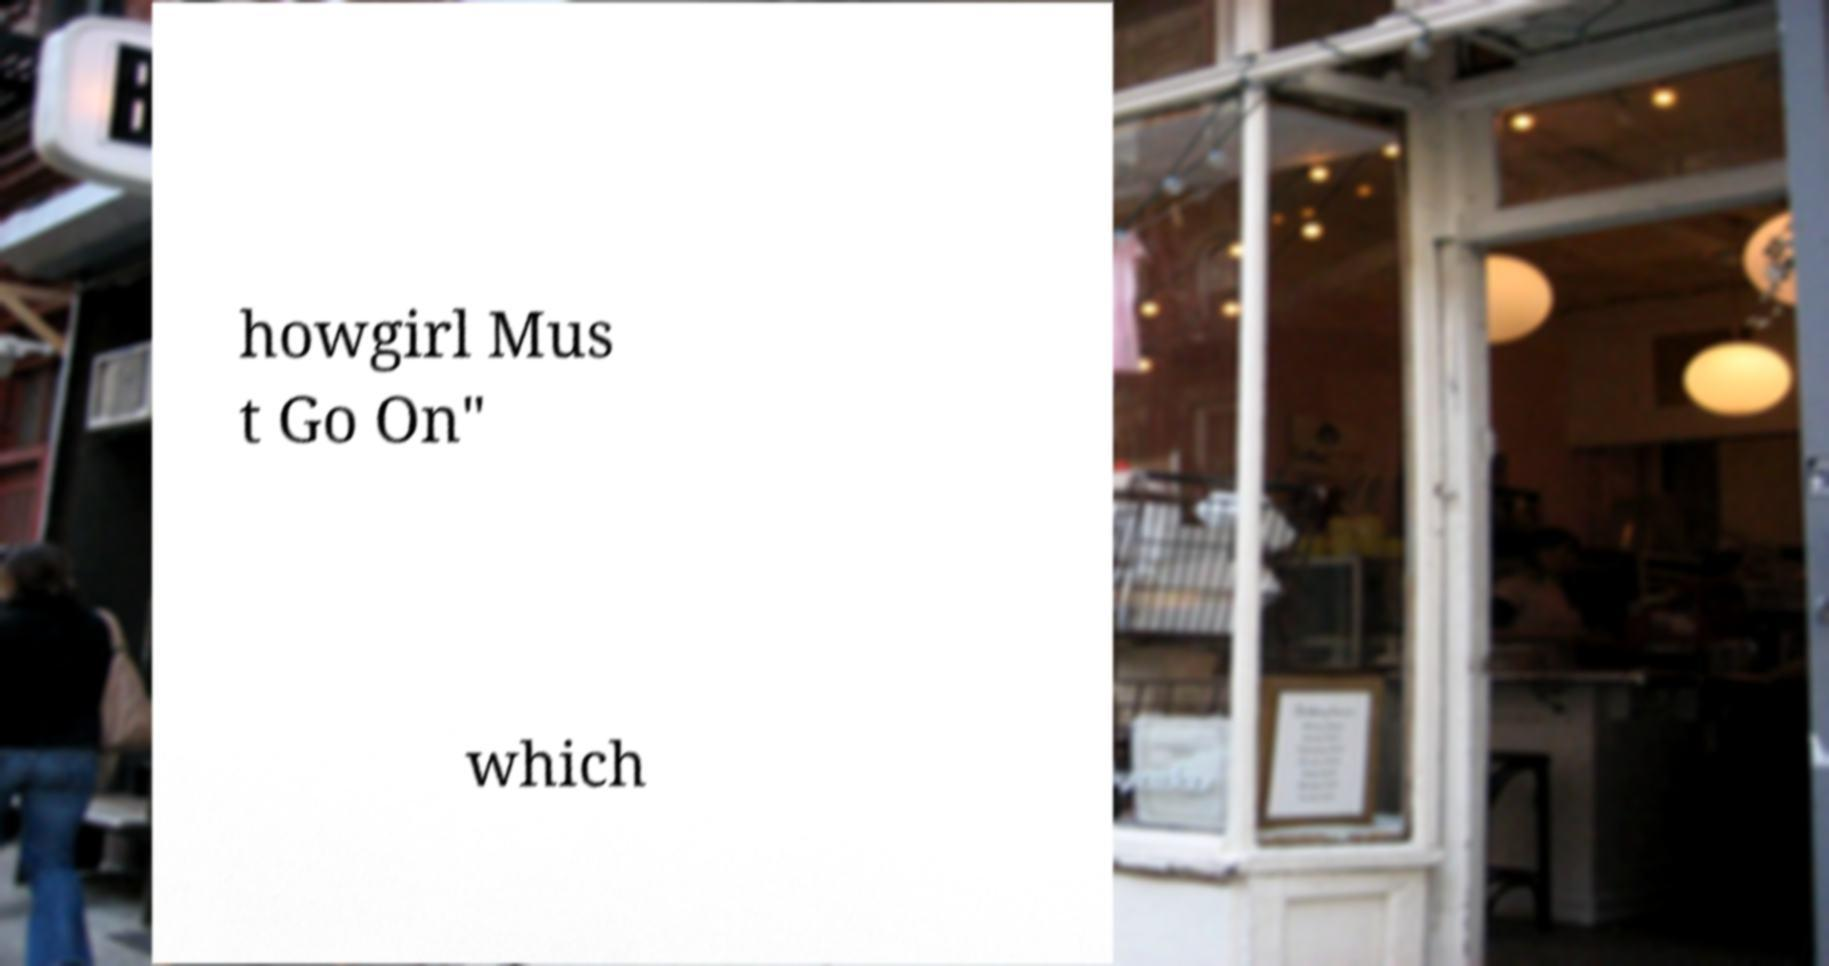I need the written content from this picture converted into text. Can you do that? howgirl Mus t Go On" which 